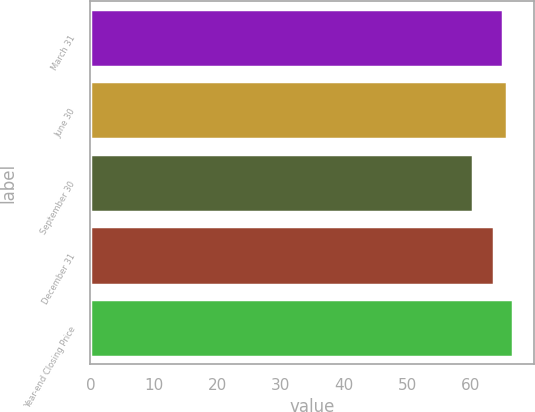Convert chart. <chart><loc_0><loc_0><loc_500><loc_500><bar_chart><fcel>March 31<fcel>June 30<fcel>September 30<fcel>December 31<fcel>Year-end Closing Price<nl><fcel>65.12<fcel>65.75<fcel>60.37<fcel>63.72<fcel>66.62<nl></chart> 